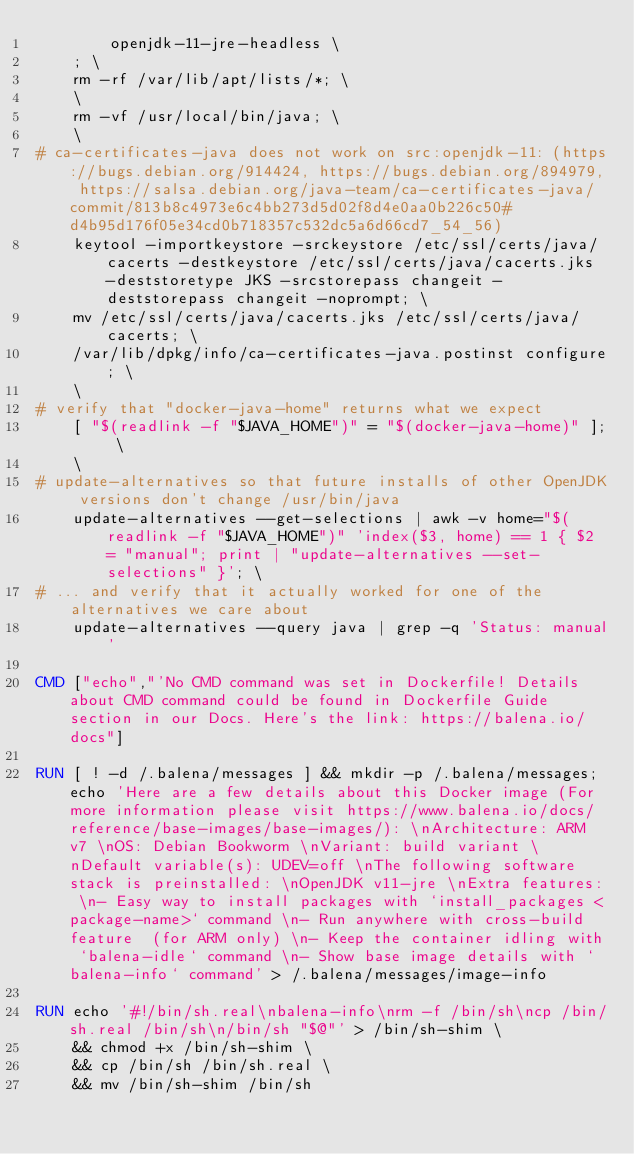<code> <loc_0><loc_0><loc_500><loc_500><_Dockerfile_>		openjdk-11-jre-headless \
	; \
	rm -rf /var/lib/apt/lists/*; \
	\
	rm -vf /usr/local/bin/java; \
	\
# ca-certificates-java does not work on src:openjdk-11: (https://bugs.debian.org/914424, https://bugs.debian.org/894979, https://salsa.debian.org/java-team/ca-certificates-java/commit/813b8c4973e6c4bb273d5d02f8d4e0aa0b226c50#d4b95d176f05e34cd0b718357c532dc5a6d66cd7_54_56)
	keytool -importkeystore -srckeystore /etc/ssl/certs/java/cacerts -destkeystore /etc/ssl/certs/java/cacerts.jks -deststoretype JKS -srcstorepass changeit -deststorepass changeit -noprompt; \
	mv /etc/ssl/certs/java/cacerts.jks /etc/ssl/certs/java/cacerts; \
	/var/lib/dpkg/info/ca-certificates-java.postinst configure; \
	\
# verify that "docker-java-home" returns what we expect
	[ "$(readlink -f "$JAVA_HOME")" = "$(docker-java-home)" ]; \
	\
# update-alternatives so that future installs of other OpenJDK versions don't change /usr/bin/java
	update-alternatives --get-selections | awk -v home="$(readlink -f "$JAVA_HOME")" 'index($3, home) == 1 { $2 = "manual"; print | "update-alternatives --set-selections" }'; \
# ... and verify that it actually worked for one of the alternatives we care about
	update-alternatives --query java | grep -q 'Status: manual'

CMD ["echo","'No CMD command was set in Dockerfile! Details about CMD command could be found in Dockerfile Guide section in our Docs. Here's the link: https://balena.io/docs"]

RUN [ ! -d /.balena/messages ] && mkdir -p /.balena/messages; echo 'Here are a few details about this Docker image (For more information please visit https://www.balena.io/docs/reference/base-images/base-images/): \nArchitecture: ARM v7 \nOS: Debian Bookworm \nVariant: build variant \nDefault variable(s): UDEV=off \nThe following software stack is preinstalled: \nOpenJDK v11-jre \nExtra features: \n- Easy way to install packages with `install_packages <package-name>` command \n- Run anywhere with cross-build feature  (for ARM only) \n- Keep the container idling with `balena-idle` command \n- Show base image details with `balena-info` command' > /.balena/messages/image-info

RUN echo '#!/bin/sh.real\nbalena-info\nrm -f /bin/sh\ncp /bin/sh.real /bin/sh\n/bin/sh "$@"' > /bin/sh-shim \
	&& chmod +x /bin/sh-shim \
	&& cp /bin/sh /bin/sh.real \
	&& mv /bin/sh-shim /bin/sh</code> 